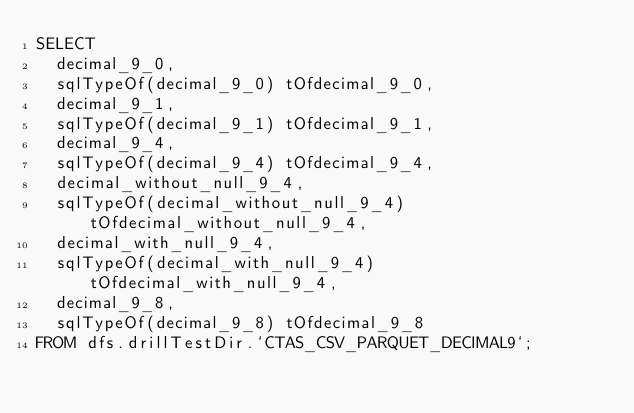<code> <loc_0><loc_0><loc_500><loc_500><_SQL_>SELECT
  decimal_9_0,
  sqlTypeOf(decimal_9_0) tOfdecimal_9_0,
  decimal_9_1,
  sqlTypeOf(decimal_9_1) tOfdecimal_9_1,
  decimal_9_4,
  sqlTypeOf(decimal_9_4) tOfdecimal_9_4,
  decimal_without_null_9_4,
  sqlTypeOf(decimal_without_null_9_4) tOfdecimal_without_null_9_4,
  decimal_with_null_9_4,
  sqlTypeOf(decimal_with_null_9_4) tOfdecimal_with_null_9_4,
  decimal_9_8,
  sqlTypeOf(decimal_9_8) tOfdecimal_9_8
FROM dfs.drillTestDir.`CTAS_CSV_PARQUET_DECIMAL9`;
</code> 